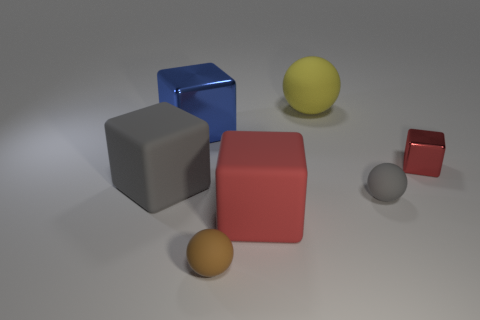Subtract all brown blocks. Subtract all brown cylinders. How many blocks are left? 4 Subtract all purple balls. How many gray blocks are left? 1 Add 3 small things. How many small grays exist? 0 Subtract all yellow spheres. Subtract all small cubes. How many objects are left? 5 Add 5 metallic blocks. How many metallic blocks are left? 7 Add 7 big yellow metal blocks. How many big yellow metal blocks exist? 7 Add 1 red matte things. How many objects exist? 8 Subtract all red cubes. How many cubes are left? 2 Subtract all blue metallic blocks. How many blocks are left? 3 Subtract 1 brown spheres. How many objects are left? 6 